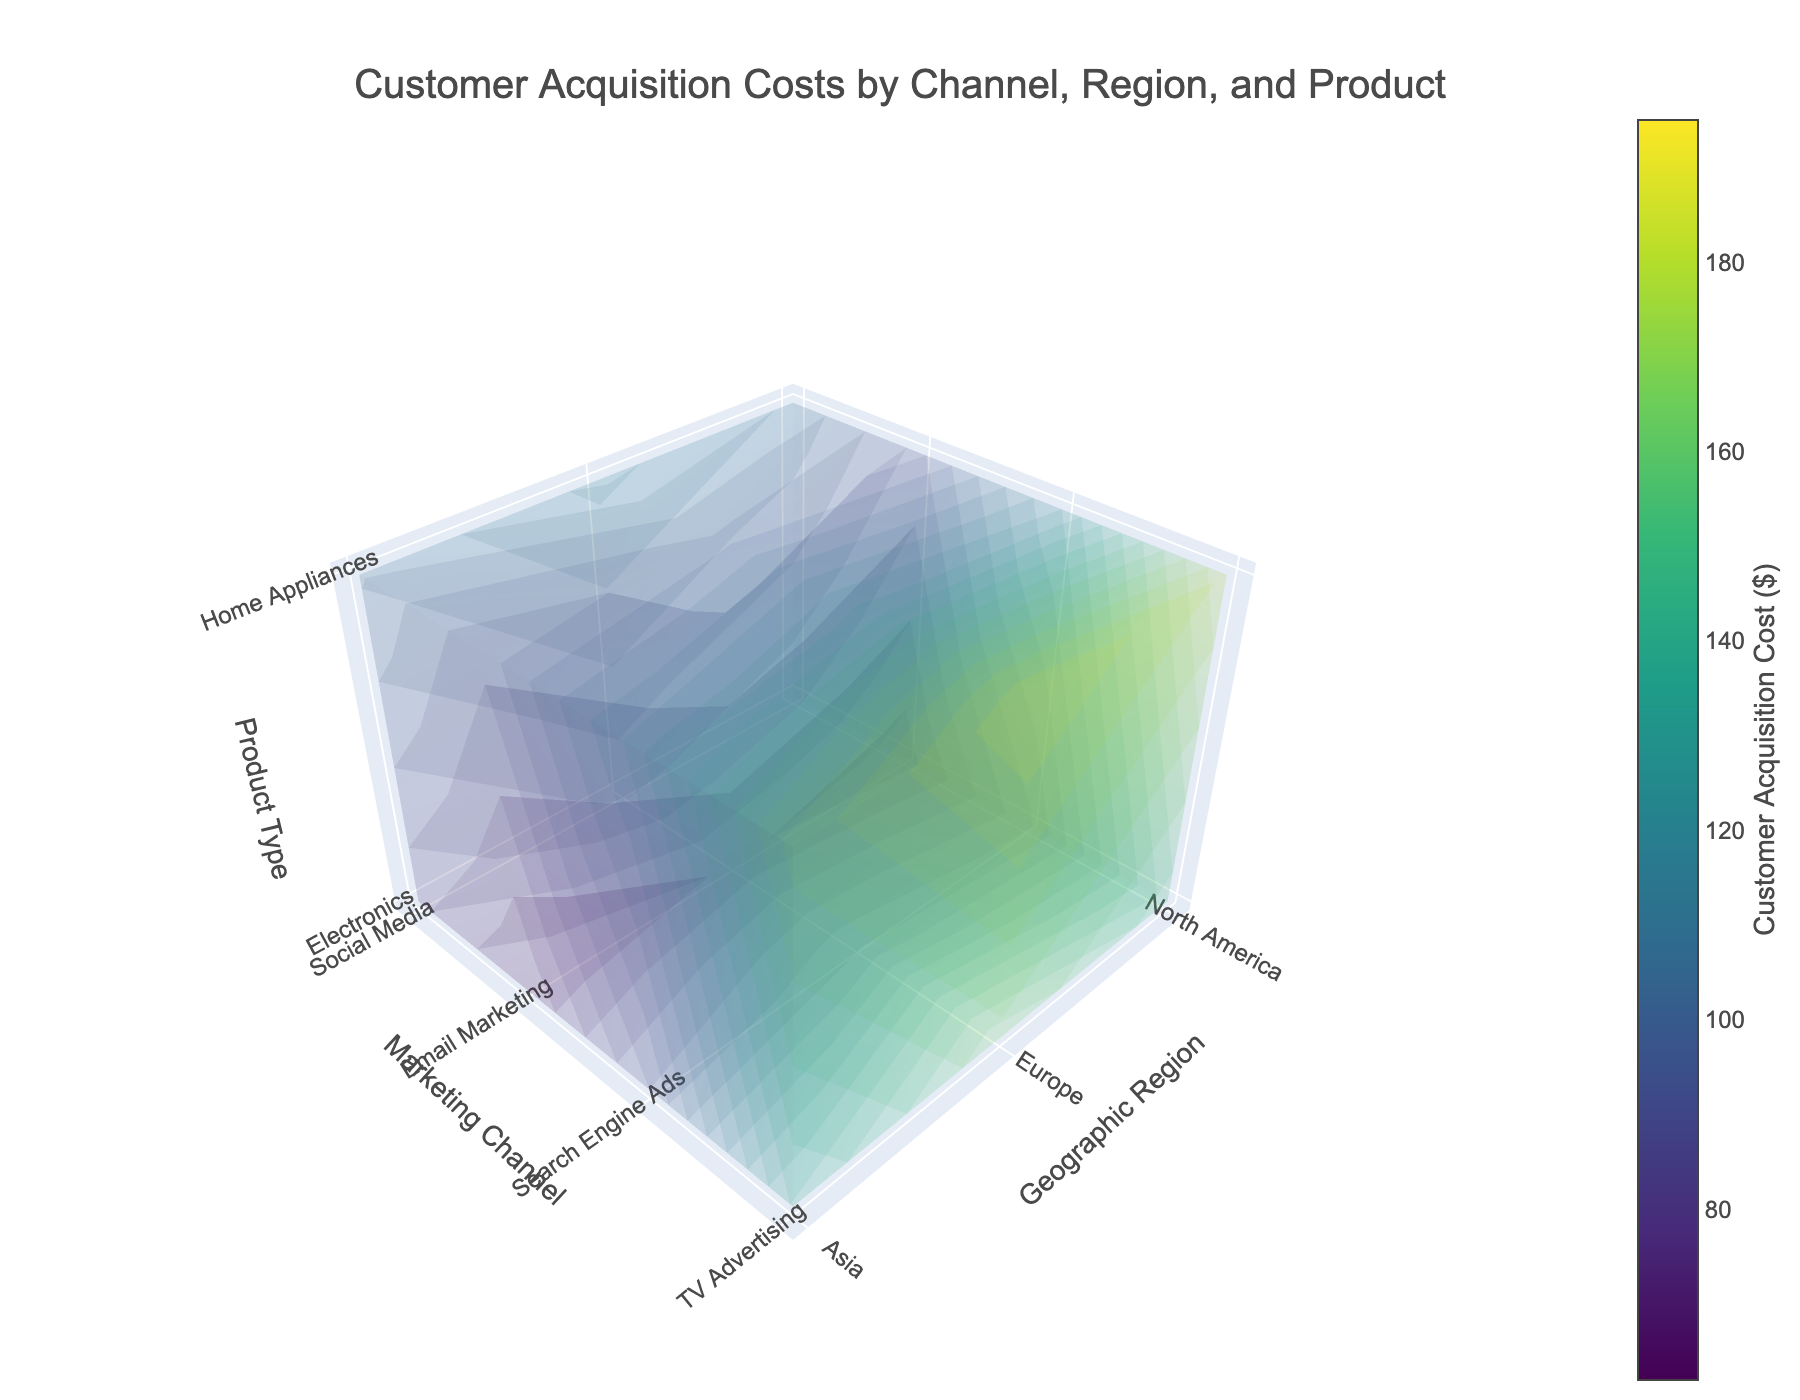What is the title of the 3D volume plot? The title is displayed at the top of the plot. It summarizes the content and context of the visualized data.
Answer: Customer Acquisition Costs by Channel, Region, and Product Which marketing channel has the lowest acquisition costs for Electronics in North America? By examining the values in the plot, we focus on the x-axis for North America, the y-axis for various marketing channels, and the z-axis for Electronics. Then compare the acquisition costs
Answer: Email Marketing How much are the acquisition costs for Home Appliances via TV Advertising in Asia? Locate the region on the x-axis (Asia), the marketing channel on the y-axis (TV Advertising), and the product type on the z-axis (Home Appliances). Then read the value.
Answer: 170 In which geographic region does Social Media have the highest customer acquisition cost for Home Appliances? Focus on the Social Media channel in various regions. Compare the acquisition costs for Home Appliances and identify the highest value region.
Answer: Europe Compare the acquisition costs of Electronics via Search Engine Ads in Europe and Asia. Which one is higher? Find the points for Search Engine Ads in Europe and Asia on the plot with Electronics as the product type. Compare their respective costs.
Answer: Europe What's the average customer acquisition cost for Home Appliances across all marketing channels in North America? Locate all Home Appliances data points in North America for different channels on the plot. Sum these values and divide by the number of points to find the average.
Answer: (110 + 88 + 125 + 180) / 4 = 125.75 How does the cost of acquiring customers through TV Advertising in Europe for Electronics compare to Home Appliances? Locate TV Advertising in Europe for both Electronics and Home Appliances on the plot. Then compare the respective costs.
Answer: Home Appliances is higher Which product type generally has higher acquisition costs through Search Engine Ads in Asia: Electronics or Home Appliances? Refer to the data points for Search Engine Ads in Asia. Compare the values for Electronics and Home Appliances.
Answer: Home Appliances What is the color range of the customer acquisition costs on the plot? Refer to the color bar on the right side of the plot that visually represents customer acquisition costs from minimum to maximum.
Answer: Viridis In which geographic region does Email Marketing have the highest customer acquisition cost for Electronics? Look at the Email Marketing data points for Electronics across different regions. Identify the highest value.
Answer: Europe 